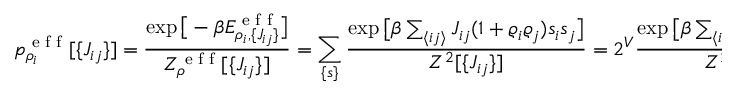Convert formula to latex. <formula><loc_0><loc_0><loc_500><loc_500>p _ { \rho _ { i } } ^ { e f f } [ \{ J _ { i j } \} ] = \frac { \exp \left [ - \beta E _ { \rho _ { i } , \{ J _ { i j } \} } ^ { e f f } \right ] } { Z _ { \rho } ^ { e f f } [ \{ J _ { i j } \} ] } = \sum _ { \{ s \} } \frac { \exp \left [ \beta \sum _ { \langle i j \rangle } J _ { i j } ( 1 + \varrho _ { i } \varrho _ { j } ) s _ { i } s _ { j } \right ] } { Z ^ { 2 } [ \{ J _ { i j } \} ] } = 2 ^ { V } \frac { \exp \left [ \beta \sum _ { \langle i j \rangle } J _ { i j } ( 1 + \varrho _ { i } \varrho _ { j } ) \right ] } { Z ^ { 2 } [ \{ J _ { i j } \} ] } ,</formula> 